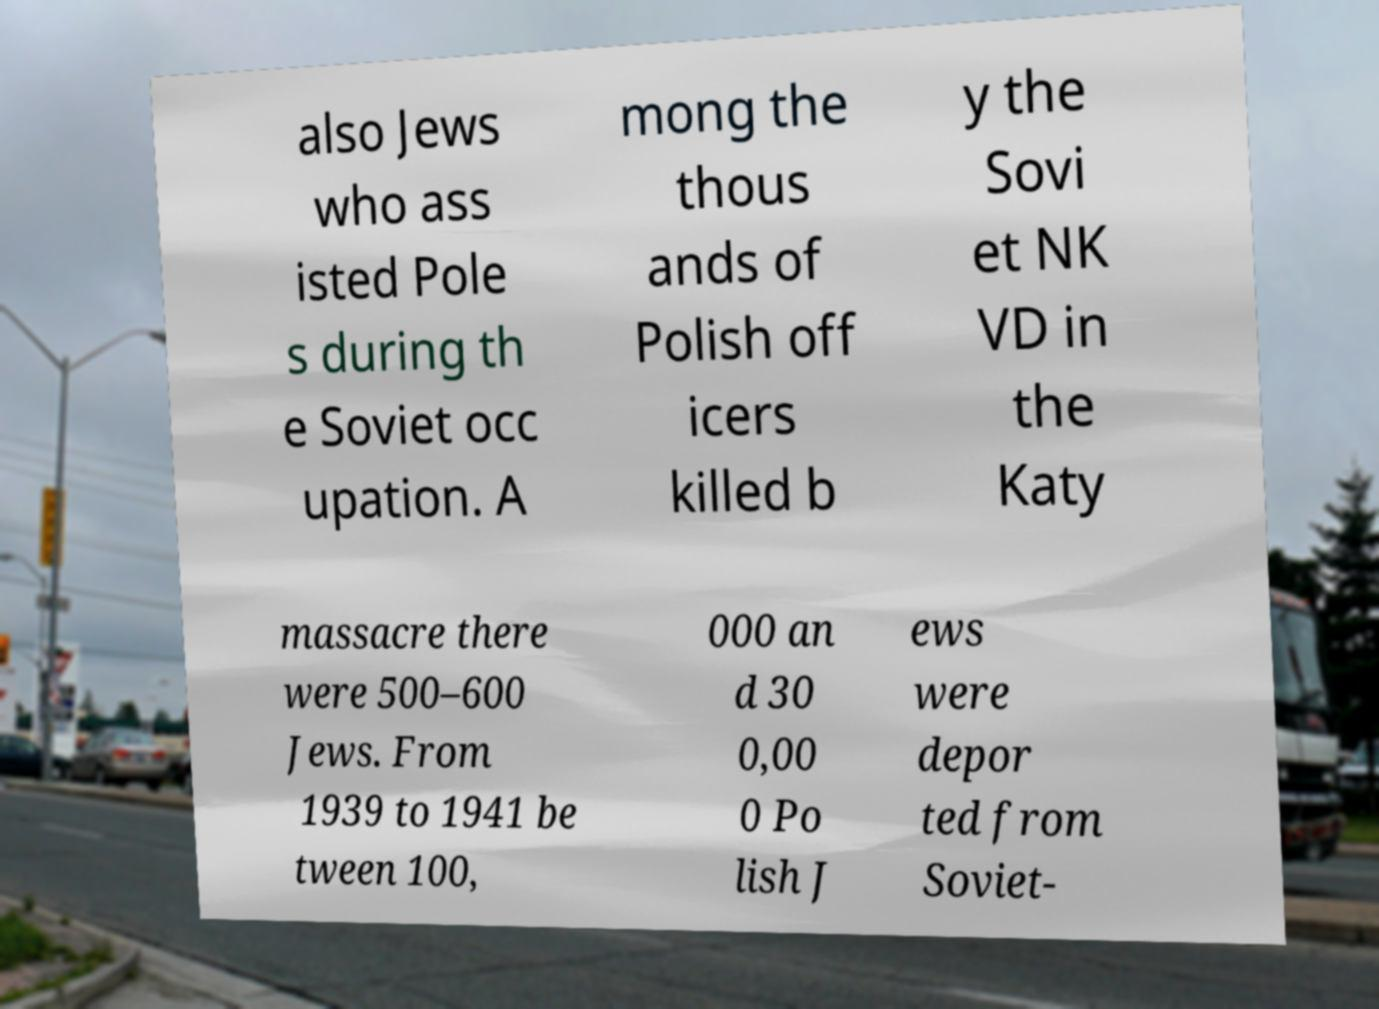Please read and relay the text visible in this image. What does it say? also Jews who ass isted Pole s during th e Soviet occ upation. A mong the thous ands of Polish off icers killed b y the Sovi et NK VD in the Katy massacre there were 500–600 Jews. From 1939 to 1941 be tween 100, 000 an d 30 0,00 0 Po lish J ews were depor ted from Soviet- 